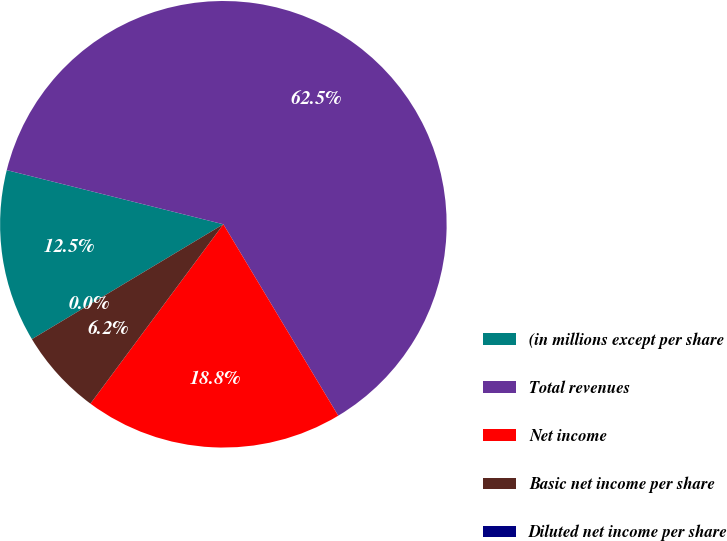Convert chart. <chart><loc_0><loc_0><loc_500><loc_500><pie_chart><fcel>(in millions except per share<fcel>Total revenues<fcel>Net income<fcel>Basic net income per share<fcel>Diluted net income per share<nl><fcel>12.5%<fcel>62.5%<fcel>18.75%<fcel>6.25%<fcel>0.0%<nl></chart> 